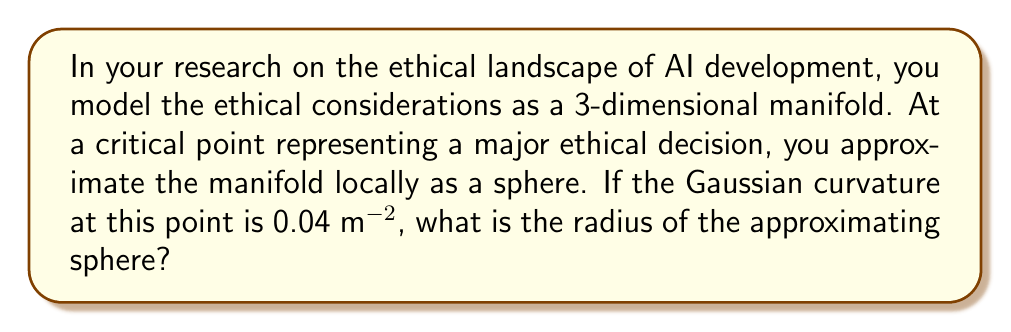Give your solution to this math problem. To solve this problem, we need to understand the relationship between Gaussian curvature and the radius of a sphere. For a sphere, the Gaussian curvature is constant at every point and is related to its radius by the following formula:

$$ K = \frac{1}{R^2} $$

Where:
$K$ is the Gaussian curvature
$R$ is the radius of the sphere

Given:
$K = 0.04 \text{ m}^{-2}$

We can substitute this into our equation:

$$ 0.04 \text{ m}^{-2} = \frac{1}{R^2} $$

To solve for $R$, we take the reciprocal of both sides and then the square root:

$$ R^2 = \frac{1}{0.04 \text{ m}^{-2}} = 25 \text{ m}^2 $$

$$ R = \sqrt{25 \text{ m}^2} = 5 \text{ m} $$

Thus, the radius of the approximating sphere is 5 meters.

This result provides a quantitative measure of how rapidly the ethical landscape is changing around this critical decision point. A smaller radius would indicate a more rapidly changing ethical landscape, while a larger radius would suggest a more gradual change.
Answer: The radius of the approximating sphere is 5 meters. 